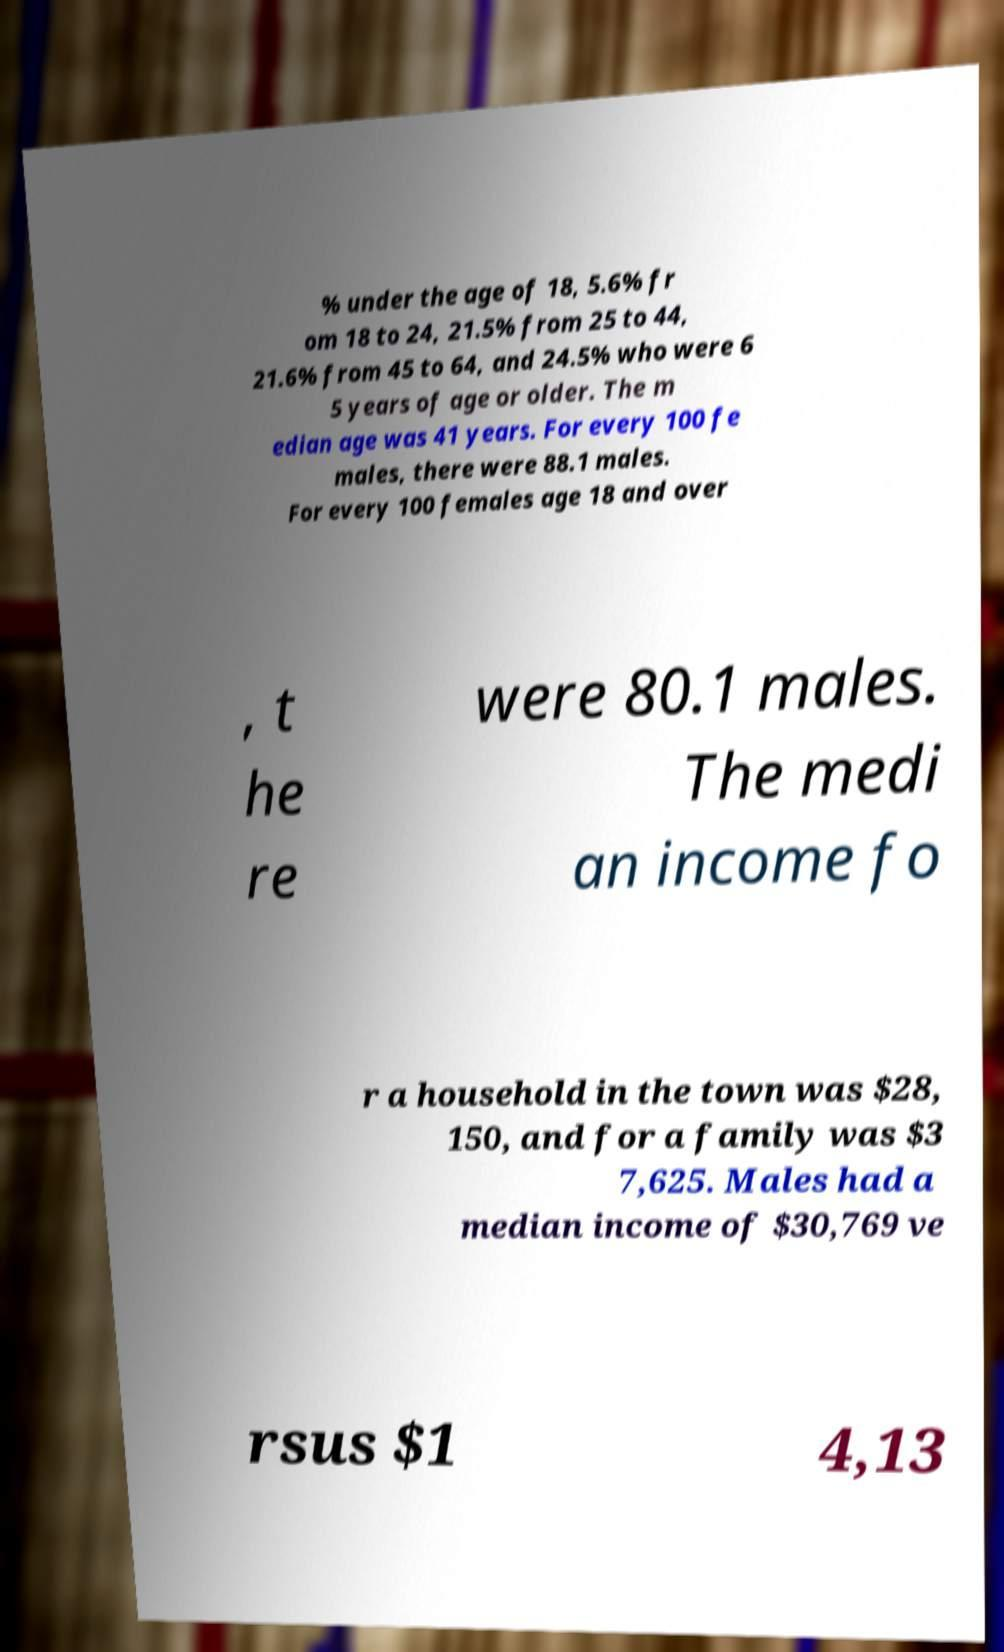Please read and relay the text visible in this image. What does it say? % under the age of 18, 5.6% fr om 18 to 24, 21.5% from 25 to 44, 21.6% from 45 to 64, and 24.5% who were 6 5 years of age or older. The m edian age was 41 years. For every 100 fe males, there were 88.1 males. For every 100 females age 18 and over , t he re were 80.1 males. The medi an income fo r a household in the town was $28, 150, and for a family was $3 7,625. Males had a median income of $30,769 ve rsus $1 4,13 